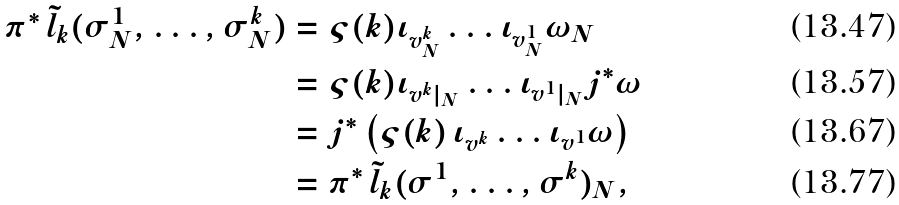<formula> <loc_0><loc_0><loc_500><loc_500>\pi ^ { * } \, \tilde { l } _ { k } ( \sigma _ { N } ^ { 1 } , \dots , \sigma _ { N } ^ { k } ) & = \varsigma ( k ) \iota _ { v _ { N } ^ { k } } \dots \iota _ { v _ { N } ^ { 1 } } \omega _ { N } \\ & = \varsigma ( k ) \iota _ { v ^ { k } | _ { N } } \dots \iota _ { v ^ { 1 } | _ { N } } j ^ { * } \omega \\ & = j ^ { * } \left ( \varsigma ( k ) \, \iota _ { v ^ { k } } \dots \iota _ { v ^ { 1 } } \omega \right ) \\ & = \pi ^ { * } \, \tilde { l } _ { k } ( \sigma ^ { 1 } , \dots , \sigma ^ { k } ) _ { N } ,</formula> 